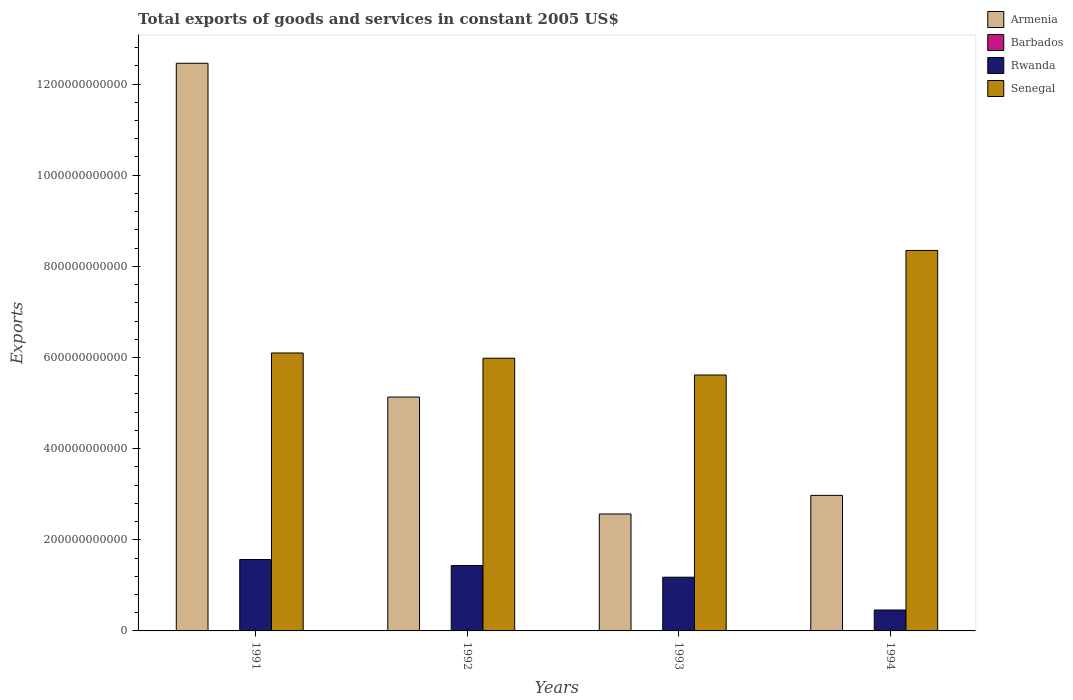How many groups of bars are there?
Offer a terse response. 4. Are the number of bars per tick equal to the number of legend labels?
Your answer should be compact. Yes. How many bars are there on the 2nd tick from the right?
Give a very brief answer. 4. What is the label of the 2nd group of bars from the left?
Keep it short and to the point. 1992. What is the total exports of goods and services in Armenia in 1992?
Make the answer very short. 5.13e+11. Across all years, what is the maximum total exports of goods and services in Armenia?
Provide a short and direct response. 1.25e+12. Across all years, what is the minimum total exports of goods and services in Armenia?
Your answer should be compact. 2.57e+11. In which year was the total exports of goods and services in Armenia maximum?
Your answer should be compact. 1991. In which year was the total exports of goods and services in Armenia minimum?
Make the answer very short. 1993. What is the total total exports of goods and services in Senegal in the graph?
Give a very brief answer. 2.60e+12. What is the difference between the total exports of goods and services in Senegal in 1993 and that in 1994?
Ensure brevity in your answer.  -2.73e+11. What is the difference between the total exports of goods and services in Armenia in 1992 and the total exports of goods and services in Barbados in 1994?
Give a very brief answer. 5.13e+11. What is the average total exports of goods and services in Armenia per year?
Your answer should be compact. 5.78e+11. In the year 1991, what is the difference between the total exports of goods and services in Armenia and total exports of goods and services in Rwanda?
Offer a very short reply. 1.09e+12. What is the ratio of the total exports of goods and services in Barbados in 1991 to that in 1993?
Keep it short and to the point. 1.08. Is the total exports of goods and services in Barbados in 1991 less than that in 1993?
Offer a very short reply. No. Is the difference between the total exports of goods and services in Armenia in 1991 and 1992 greater than the difference between the total exports of goods and services in Rwanda in 1991 and 1992?
Your answer should be compact. Yes. What is the difference between the highest and the second highest total exports of goods and services in Rwanda?
Your answer should be compact. 1.33e+1. What is the difference between the highest and the lowest total exports of goods and services in Senegal?
Provide a succinct answer. 2.73e+11. In how many years, is the total exports of goods and services in Rwanda greater than the average total exports of goods and services in Rwanda taken over all years?
Provide a succinct answer. 3. What does the 2nd bar from the left in 1993 represents?
Your answer should be compact. Barbados. What does the 2nd bar from the right in 1991 represents?
Provide a short and direct response. Rwanda. How many bars are there?
Your response must be concise. 16. What is the difference between two consecutive major ticks on the Y-axis?
Ensure brevity in your answer.  2.00e+11. Are the values on the major ticks of Y-axis written in scientific E-notation?
Offer a terse response. No. Does the graph contain any zero values?
Provide a succinct answer. No. Does the graph contain grids?
Offer a terse response. No. How many legend labels are there?
Provide a succinct answer. 4. How are the legend labels stacked?
Give a very brief answer. Vertical. What is the title of the graph?
Offer a very short reply. Total exports of goods and services in constant 2005 US$. Does "Syrian Arab Republic" appear as one of the legend labels in the graph?
Ensure brevity in your answer.  No. What is the label or title of the Y-axis?
Offer a terse response. Exports. What is the Exports in Armenia in 1991?
Offer a terse response. 1.25e+12. What is the Exports of Barbados in 1991?
Provide a succinct answer. 3.92e+08. What is the Exports of Rwanda in 1991?
Give a very brief answer. 1.57e+11. What is the Exports in Senegal in 1991?
Ensure brevity in your answer.  6.10e+11. What is the Exports of Armenia in 1992?
Offer a terse response. 5.13e+11. What is the Exports in Barbados in 1992?
Give a very brief answer. 3.59e+08. What is the Exports in Rwanda in 1992?
Offer a terse response. 1.43e+11. What is the Exports of Senegal in 1992?
Ensure brevity in your answer.  5.98e+11. What is the Exports in Armenia in 1993?
Give a very brief answer. 2.57e+11. What is the Exports in Barbados in 1993?
Your answer should be compact. 3.62e+08. What is the Exports in Rwanda in 1993?
Your answer should be very brief. 1.18e+11. What is the Exports in Senegal in 1993?
Provide a succinct answer. 5.62e+11. What is the Exports of Armenia in 1994?
Provide a succinct answer. 2.97e+11. What is the Exports in Barbados in 1994?
Keep it short and to the point. 4.60e+08. What is the Exports in Rwanda in 1994?
Your answer should be very brief. 4.59e+1. What is the Exports of Senegal in 1994?
Keep it short and to the point. 8.35e+11. Across all years, what is the maximum Exports in Armenia?
Keep it short and to the point. 1.25e+12. Across all years, what is the maximum Exports of Barbados?
Keep it short and to the point. 4.60e+08. Across all years, what is the maximum Exports of Rwanda?
Your response must be concise. 1.57e+11. Across all years, what is the maximum Exports in Senegal?
Your answer should be compact. 8.35e+11. Across all years, what is the minimum Exports of Armenia?
Provide a short and direct response. 2.57e+11. Across all years, what is the minimum Exports in Barbados?
Give a very brief answer. 3.59e+08. Across all years, what is the minimum Exports in Rwanda?
Keep it short and to the point. 4.59e+1. Across all years, what is the minimum Exports of Senegal?
Provide a succinct answer. 5.62e+11. What is the total Exports of Armenia in the graph?
Offer a terse response. 2.31e+12. What is the total Exports of Barbados in the graph?
Keep it short and to the point. 1.57e+09. What is the total Exports in Rwanda in the graph?
Offer a terse response. 4.64e+11. What is the total Exports in Senegal in the graph?
Provide a short and direct response. 2.60e+12. What is the difference between the Exports of Armenia in 1991 and that in 1992?
Provide a short and direct response. 7.32e+11. What is the difference between the Exports of Barbados in 1991 and that in 1992?
Keep it short and to the point. 3.30e+07. What is the difference between the Exports of Rwanda in 1991 and that in 1992?
Your answer should be very brief. 1.33e+1. What is the difference between the Exports in Senegal in 1991 and that in 1992?
Your answer should be compact. 1.15e+1. What is the difference between the Exports in Armenia in 1991 and that in 1993?
Keep it short and to the point. 9.89e+11. What is the difference between the Exports in Barbados in 1991 and that in 1993?
Provide a succinct answer. 3.00e+07. What is the difference between the Exports in Rwanda in 1991 and that in 1993?
Your response must be concise. 3.88e+1. What is the difference between the Exports of Senegal in 1991 and that in 1993?
Keep it short and to the point. 4.83e+1. What is the difference between the Exports of Armenia in 1991 and that in 1994?
Make the answer very short. 9.48e+11. What is the difference between the Exports of Barbados in 1991 and that in 1994?
Ensure brevity in your answer.  -6.80e+07. What is the difference between the Exports of Rwanda in 1991 and that in 1994?
Keep it short and to the point. 1.11e+11. What is the difference between the Exports of Senegal in 1991 and that in 1994?
Provide a succinct answer. -2.25e+11. What is the difference between the Exports of Armenia in 1992 and that in 1993?
Keep it short and to the point. 2.57e+11. What is the difference between the Exports in Barbados in 1992 and that in 1993?
Provide a succinct answer. -3.00e+06. What is the difference between the Exports of Rwanda in 1992 and that in 1993?
Give a very brief answer. 2.55e+1. What is the difference between the Exports in Senegal in 1992 and that in 1993?
Make the answer very short. 3.68e+1. What is the difference between the Exports in Armenia in 1992 and that in 1994?
Make the answer very short. 2.16e+11. What is the difference between the Exports in Barbados in 1992 and that in 1994?
Make the answer very short. -1.01e+08. What is the difference between the Exports of Rwanda in 1992 and that in 1994?
Make the answer very short. 9.75e+1. What is the difference between the Exports in Senegal in 1992 and that in 1994?
Your answer should be very brief. -2.36e+11. What is the difference between the Exports of Armenia in 1993 and that in 1994?
Your answer should be compact. -4.08e+1. What is the difference between the Exports of Barbados in 1993 and that in 1994?
Offer a terse response. -9.80e+07. What is the difference between the Exports in Rwanda in 1993 and that in 1994?
Provide a short and direct response. 7.20e+1. What is the difference between the Exports in Senegal in 1993 and that in 1994?
Your answer should be very brief. -2.73e+11. What is the difference between the Exports in Armenia in 1991 and the Exports in Barbados in 1992?
Offer a terse response. 1.25e+12. What is the difference between the Exports of Armenia in 1991 and the Exports of Rwanda in 1992?
Your answer should be very brief. 1.10e+12. What is the difference between the Exports of Armenia in 1991 and the Exports of Senegal in 1992?
Offer a very short reply. 6.47e+11. What is the difference between the Exports of Barbados in 1991 and the Exports of Rwanda in 1992?
Give a very brief answer. -1.43e+11. What is the difference between the Exports in Barbados in 1991 and the Exports in Senegal in 1992?
Keep it short and to the point. -5.98e+11. What is the difference between the Exports of Rwanda in 1991 and the Exports of Senegal in 1992?
Offer a terse response. -4.42e+11. What is the difference between the Exports in Armenia in 1991 and the Exports in Barbados in 1993?
Offer a terse response. 1.25e+12. What is the difference between the Exports in Armenia in 1991 and the Exports in Rwanda in 1993?
Offer a very short reply. 1.13e+12. What is the difference between the Exports of Armenia in 1991 and the Exports of Senegal in 1993?
Your answer should be very brief. 6.84e+11. What is the difference between the Exports of Barbados in 1991 and the Exports of Rwanda in 1993?
Ensure brevity in your answer.  -1.17e+11. What is the difference between the Exports of Barbados in 1991 and the Exports of Senegal in 1993?
Keep it short and to the point. -5.61e+11. What is the difference between the Exports in Rwanda in 1991 and the Exports in Senegal in 1993?
Provide a short and direct response. -4.05e+11. What is the difference between the Exports of Armenia in 1991 and the Exports of Barbados in 1994?
Provide a short and direct response. 1.25e+12. What is the difference between the Exports in Armenia in 1991 and the Exports in Rwanda in 1994?
Give a very brief answer. 1.20e+12. What is the difference between the Exports in Armenia in 1991 and the Exports in Senegal in 1994?
Your answer should be compact. 4.11e+11. What is the difference between the Exports of Barbados in 1991 and the Exports of Rwanda in 1994?
Keep it short and to the point. -4.55e+1. What is the difference between the Exports in Barbados in 1991 and the Exports in Senegal in 1994?
Provide a short and direct response. -8.34e+11. What is the difference between the Exports of Rwanda in 1991 and the Exports of Senegal in 1994?
Keep it short and to the point. -6.78e+11. What is the difference between the Exports of Armenia in 1992 and the Exports of Barbados in 1993?
Keep it short and to the point. 5.13e+11. What is the difference between the Exports of Armenia in 1992 and the Exports of Rwanda in 1993?
Make the answer very short. 3.95e+11. What is the difference between the Exports in Armenia in 1992 and the Exports in Senegal in 1993?
Make the answer very short. -4.84e+1. What is the difference between the Exports of Barbados in 1992 and the Exports of Rwanda in 1993?
Ensure brevity in your answer.  -1.17e+11. What is the difference between the Exports of Barbados in 1992 and the Exports of Senegal in 1993?
Make the answer very short. -5.61e+11. What is the difference between the Exports in Rwanda in 1992 and the Exports in Senegal in 1993?
Provide a succinct answer. -4.18e+11. What is the difference between the Exports of Armenia in 1992 and the Exports of Barbados in 1994?
Ensure brevity in your answer.  5.13e+11. What is the difference between the Exports in Armenia in 1992 and the Exports in Rwanda in 1994?
Give a very brief answer. 4.67e+11. What is the difference between the Exports in Armenia in 1992 and the Exports in Senegal in 1994?
Provide a short and direct response. -3.22e+11. What is the difference between the Exports in Barbados in 1992 and the Exports in Rwanda in 1994?
Provide a succinct answer. -4.55e+1. What is the difference between the Exports in Barbados in 1992 and the Exports in Senegal in 1994?
Offer a terse response. -8.34e+11. What is the difference between the Exports in Rwanda in 1992 and the Exports in Senegal in 1994?
Provide a short and direct response. -6.91e+11. What is the difference between the Exports of Armenia in 1993 and the Exports of Barbados in 1994?
Keep it short and to the point. 2.56e+11. What is the difference between the Exports of Armenia in 1993 and the Exports of Rwanda in 1994?
Keep it short and to the point. 2.11e+11. What is the difference between the Exports in Armenia in 1993 and the Exports in Senegal in 1994?
Give a very brief answer. -5.78e+11. What is the difference between the Exports in Barbados in 1993 and the Exports in Rwanda in 1994?
Your response must be concise. -4.55e+1. What is the difference between the Exports in Barbados in 1993 and the Exports in Senegal in 1994?
Your answer should be compact. -8.34e+11. What is the difference between the Exports in Rwanda in 1993 and the Exports in Senegal in 1994?
Your answer should be very brief. -7.17e+11. What is the average Exports in Armenia per year?
Offer a very short reply. 5.78e+11. What is the average Exports of Barbados per year?
Your answer should be very brief. 3.93e+08. What is the average Exports in Rwanda per year?
Offer a very short reply. 1.16e+11. What is the average Exports of Senegal per year?
Make the answer very short. 6.51e+11. In the year 1991, what is the difference between the Exports of Armenia and Exports of Barbados?
Your answer should be very brief. 1.25e+12. In the year 1991, what is the difference between the Exports in Armenia and Exports in Rwanda?
Provide a short and direct response. 1.09e+12. In the year 1991, what is the difference between the Exports of Armenia and Exports of Senegal?
Your response must be concise. 6.36e+11. In the year 1991, what is the difference between the Exports in Barbados and Exports in Rwanda?
Your answer should be very brief. -1.56e+11. In the year 1991, what is the difference between the Exports in Barbados and Exports in Senegal?
Ensure brevity in your answer.  -6.10e+11. In the year 1991, what is the difference between the Exports in Rwanda and Exports in Senegal?
Keep it short and to the point. -4.53e+11. In the year 1992, what is the difference between the Exports in Armenia and Exports in Barbados?
Your answer should be very brief. 5.13e+11. In the year 1992, what is the difference between the Exports in Armenia and Exports in Rwanda?
Make the answer very short. 3.70e+11. In the year 1992, what is the difference between the Exports in Armenia and Exports in Senegal?
Make the answer very short. -8.52e+1. In the year 1992, what is the difference between the Exports of Barbados and Exports of Rwanda?
Provide a succinct answer. -1.43e+11. In the year 1992, what is the difference between the Exports of Barbados and Exports of Senegal?
Make the answer very short. -5.98e+11. In the year 1992, what is the difference between the Exports in Rwanda and Exports in Senegal?
Offer a terse response. -4.55e+11. In the year 1993, what is the difference between the Exports of Armenia and Exports of Barbados?
Keep it short and to the point. 2.56e+11. In the year 1993, what is the difference between the Exports in Armenia and Exports in Rwanda?
Your answer should be compact. 1.39e+11. In the year 1993, what is the difference between the Exports of Armenia and Exports of Senegal?
Make the answer very short. -3.05e+11. In the year 1993, what is the difference between the Exports of Barbados and Exports of Rwanda?
Offer a terse response. -1.17e+11. In the year 1993, what is the difference between the Exports in Barbados and Exports in Senegal?
Your answer should be compact. -5.61e+11. In the year 1993, what is the difference between the Exports of Rwanda and Exports of Senegal?
Make the answer very short. -4.44e+11. In the year 1994, what is the difference between the Exports of Armenia and Exports of Barbados?
Offer a very short reply. 2.97e+11. In the year 1994, what is the difference between the Exports of Armenia and Exports of Rwanda?
Your response must be concise. 2.52e+11. In the year 1994, what is the difference between the Exports in Armenia and Exports in Senegal?
Ensure brevity in your answer.  -5.37e+11. In the year 1994, what is the difference between the Exports of Barbados and Exports of Rwanda?
Your response must be concise. -4.54e+1. In the year 1994, what is the difference between the Exports in Barbados and Exports in Senegal?
Your answer should be compact. -8.34e+11. In the year 1994, what is the difference between the Exports of Rwanda and Exports of Senegal?
Your response must be concise. -7.89e+11. What is the ratio of the Exports in Armenia in 1991 to that in 1992?
Offer a terse response. 2.43. What is the ratio of the Exports of Barbados in 1991 to that in 1992?
Provide a short and direct response. 1.09. What is the ratio of the Exports of Rwanda in 1991 to that in 1992?
Offer a terse response. 1.09. What is the ratio of the Exports of Senegal in 1991 to that in 1992?
Your response must be concise. 1.02. What is the ratio of the Exports of Armenia in 1991 to that in 1993?
Ensure brevity in your answer.  4.85. What is the ratio of the Exports in Barbados in 1991 to that in 1993?
Your response must be concise. 1.08. What is the ratio of the Exports of Rwanda in 1991 to that in 1993?
Provide a succinct answer. 1.33. What is the ratio of the Exports in Senegal in 1991 to that in 1993?
Offer a very short reply. 1.09. What is the ratio of the Exports of Armenia in 1991 to that in 1994?
Make the answer very short. 4.19. What is the ratio of the Exports in Barbados in 1991 to that in 1994?
Make the answer very short. 0.85. What is the ratio of the Exports of Rwanda in 1991 to that in 1994?
Give a very brief answer. 3.41. What is the ratio of the Exports in Senegal in 1991 to that in 1994?
Your response must be concise. 0.73. What is the ratio of the Exports in Barbados in 1992 to that in 1993?
Your answer should be compact. 0.99. What is the ratio of the Exports of Rwanda in 1992 to that in 1993?
Ensure brevity in your answer.  1.22. What is the ratio of the Exports in Senegal in 1992 to that in 1993?
Offer a terse response. 1.07. What is the ratio of the Exports in Armenia in 1992 to that in 1994?
Provide a short and direct response. 1.73. What is the ratio of the Exports of Barbados in 1992 to that in 1994?
Give a very brief answer. 0.78. What is the ratio of the Exports in Rwanda in 1992 to that in 1994?
Your answer should be compact. 3.12. What is the ratio of the Exports in Senegal in 1992 to that in 1994?
Provide a succinct answer. 0.72. What is the ratio of the Exports of Armenia in 1993 to that in 1994?
Make the answer very short. 0.86. What is the ratio of the Exports in Barbados in 1993 to that in 1994?
Offer a very short reply. 0.79. What is the ratio of the Exports in Rwanda in 1993 to that in 1994?
Give a very brief answer. 2.57. What is the ratio of the Exports in Senegal in 1993 to that in 1994?
Ensure brevity in your answer.  0.67. What is the difference between the highest and the second highest Exports in Armenia?
Your answer should be compact. 7.32e+11. What is the difference between the highest and the second highest Exports of Barbados?
Provide a succinct answer. 6.80e+07. What is the difference between the highest and the second highest Exports in Rwanda?
Provide a succinct answer. 1.33e+1. What is the difference between the highest and the second highest Exports of Senegal?
Provide a succinct answer. 2.25e+11. What is the difference between the highest and the lowest Exports of Armenia?
Ensure brevity in your answer.  9.89e+11. What is the difference between the highest and the lowest Exports of Barbados?
Make the answer very short. 1.01e+08. What is the difference between the highest and the lowest Exports in Rwanda?
Offer a very short reply. 1.11e+11. What is the difference between the highest and the lowest Exports of Senegal?
Keep it short and to the point. 2.73e+11. 